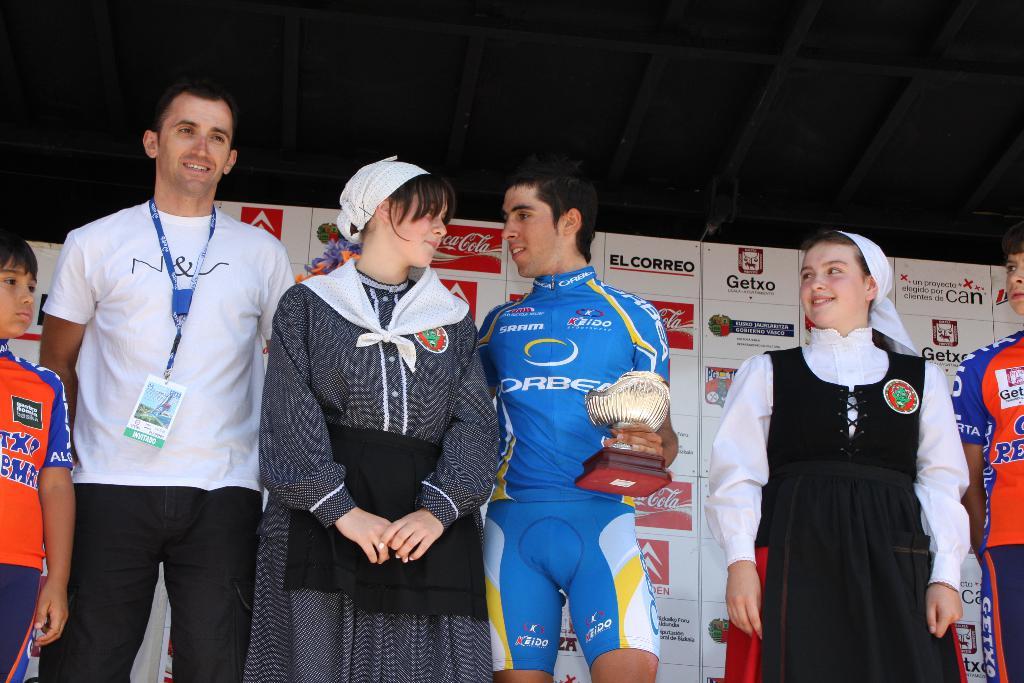Is getxo a sponsor?
Offer a very short reply. Yes. 